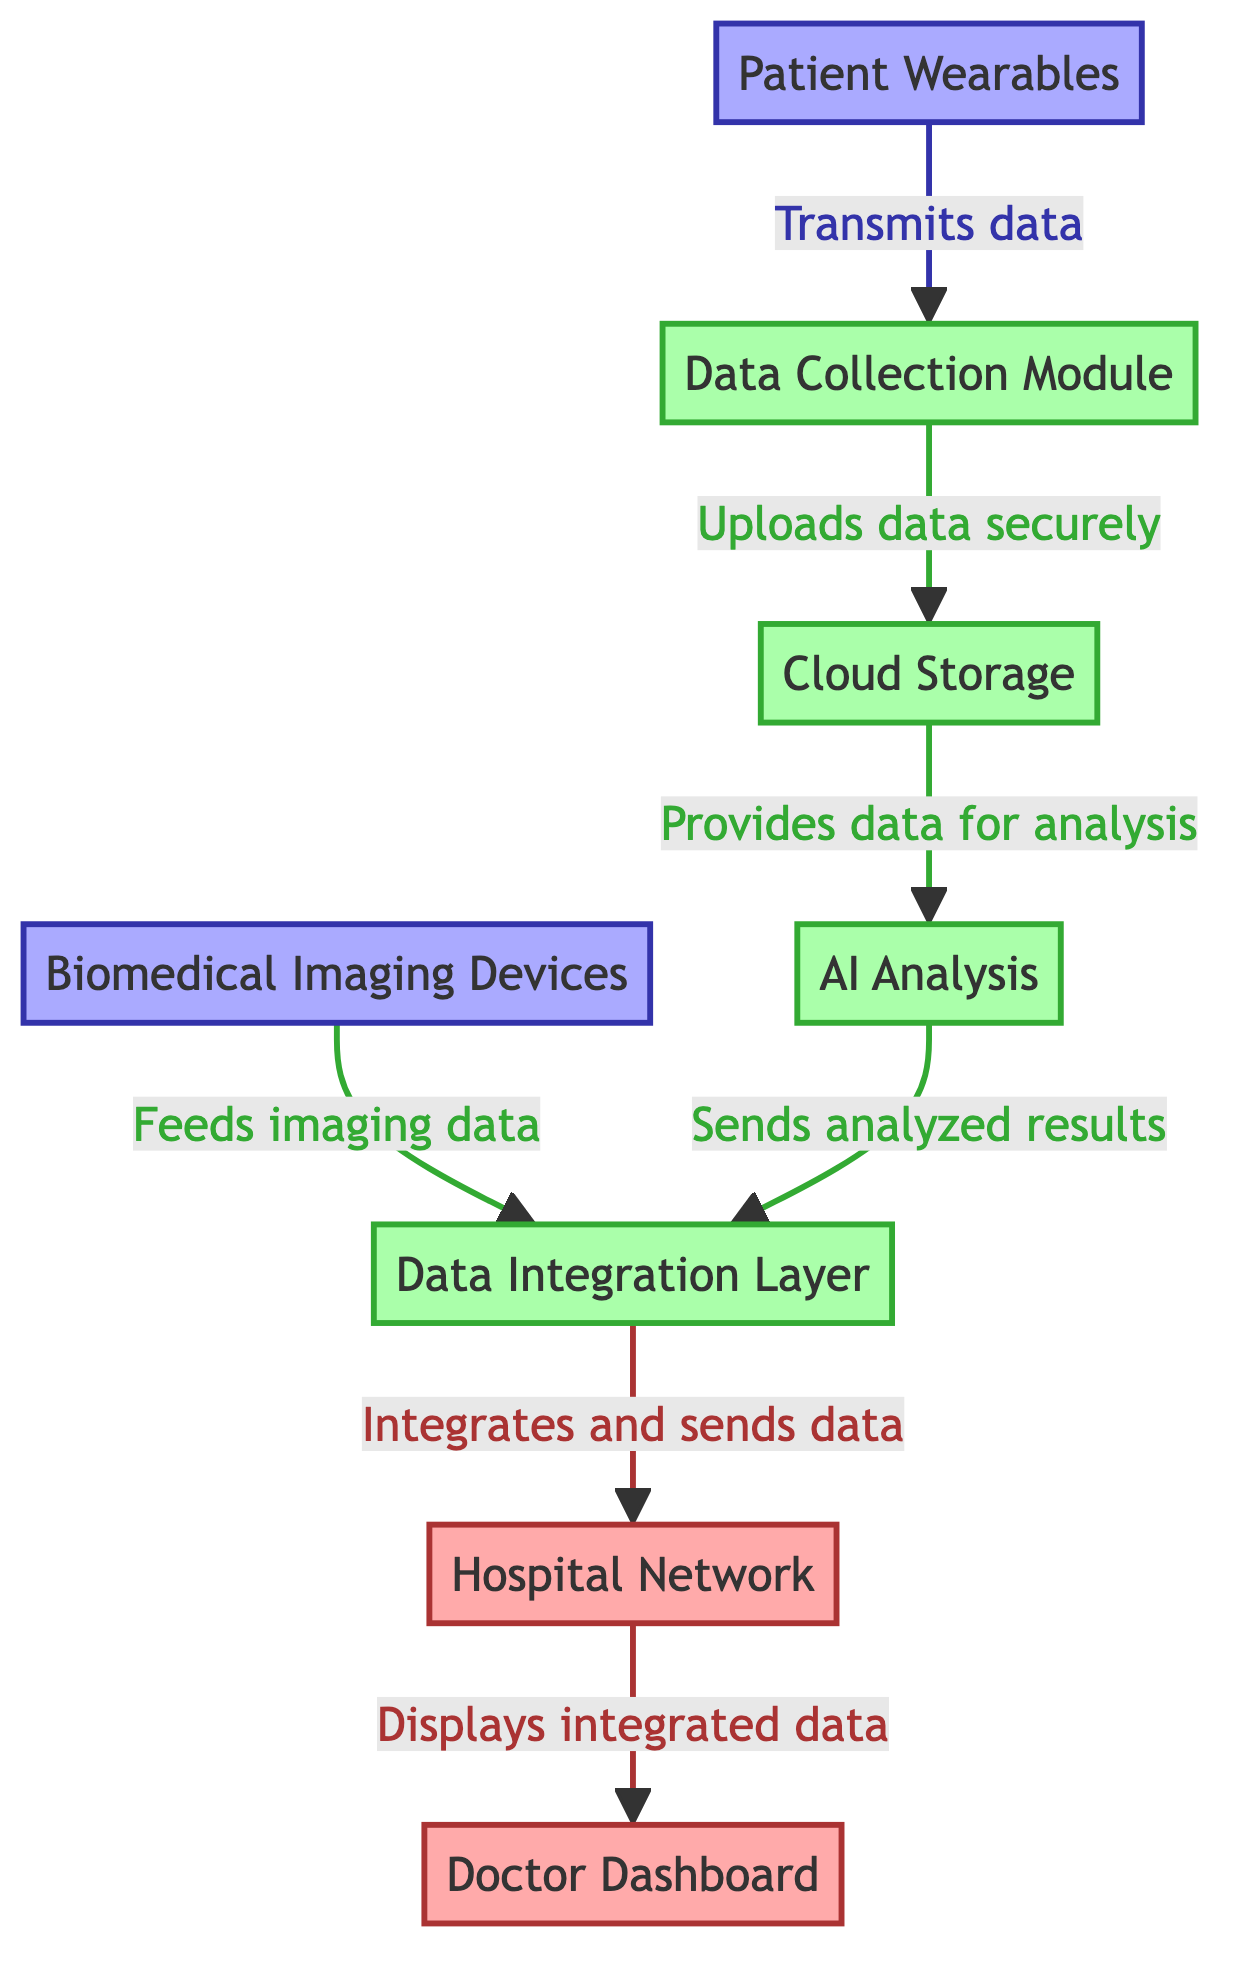What node receives data from Patient Wearables? The diagram indicates that Patient Wearables transmit data to the Data Collection Module, which is the node that directly receives this data.
Answer: Data Collection Module How many nodes are present in the diagram? The diagram includes eight distinct nodes: Patient Wearables, Data Collection Module, Cloud Storage, AI Analysis, Biomedical Imaging Devices, Data Integration Layer, Hospital Network, and Doctor Dashboard.
Answer: Eight What type of data do Biomedical Imaging Devices provide? According to the diagram, Biomedical Imaging Devices feed imaging data into the Data Integration Layer, which is the specified type of data provided by this node.
Answer: Imaging data What is the final output node in the data flow? Following the flow of the diagram, the final output node is the Doctor Dashboard, which displays the integrated data after it has passed through all previous nodes.
Answer: Doctor Dashboard Which module analyzes data after it is uploaded to Cloud Storage? The diagram shows that after data is uploaded securely to Cloud Storage, it is then analyzed by the AI Analysis module. This module is specifically designated for data analysis in the flow.
Answer: AI Analysis What does the Data Integration Layer do with the data from AI Analysis? The diagram specifies that the Data Integration Layer integrates and sends data to the Hospital Network after receiving analyzed results from AI Analysis. This indicates its role in merging and transmitting data.
Answer: Integrates and sends data How is data uploaded from the Data Collection Module to Cloud Storage? The diagram explicitly states that data is uploaded securely from the Data Collection Module to Cloud Storage, indicating that the data transfer has a focus on security.
Answer: Securely What relationship exists between the Cloud Storage and AI Analysis nodes? The relationship is that Cloud Storage provides data for analysis to the AI Analysis node, indicating a directional flow of information from one to another.
Answer: Provides data for analysis 